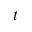Convert formula to latex. <formula><loc_0><loc_0><loc_500><loc_500>t</formula> 